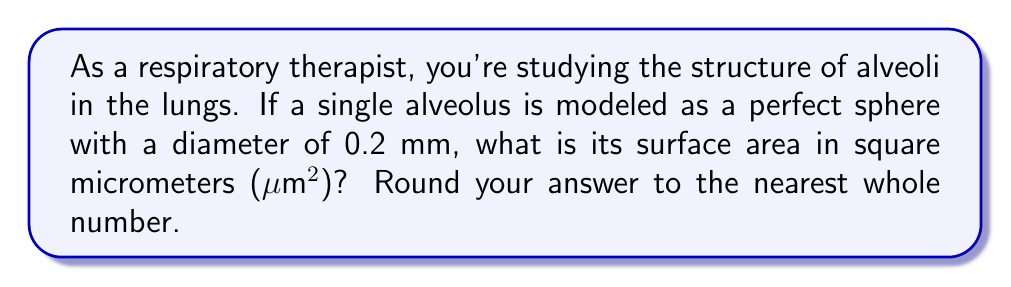What is the answer to this math problem? To solve this problem, we'll follow these steps:

1) Recall the formula for the surface area of a sphere:
   $$A = 4\pi r^2$$
   where $A$ is the surface area and $r$ is the radius.

2) We're given the diameter (0.2 mm), so we need to find the radius:
   $$r = \frac{diameter}{2} = \frac{0.2 \text{ mm}}{2} = 0.1 \text{ mm}$$

3) Convert the radius to micrometers:
   $$0.1 \text{ mm} = 100 \text{ μm}$$

4) Now we can substitute this into our formula:
   $$A = 4\pi (100 \text{ μm})^2$$

5) Calculate:
   $$A = 4\pi (10000 \text{ μm}^2)$$
   $$A = 40000\pi \text{ μm}^2$$
   $$A \approx 125663.71 \text{ μm}^2$$

6) Rounding to the nearest whole number:
   $$A \approx 125664 \text{ μm}^2$$

This calculation gives us the surface area of a single alveolus, which is crucial for understanding gas exchange in the lungs.
Answer: 125664 μm² 